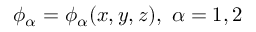Convert formula to latex. <formula><loc_0><loc_0><loc_500><loc_500>\phi _ { \alpha } = \phi _ { \alpha } ( x , y , z ) , \alpha = 1 , 2</formula> 